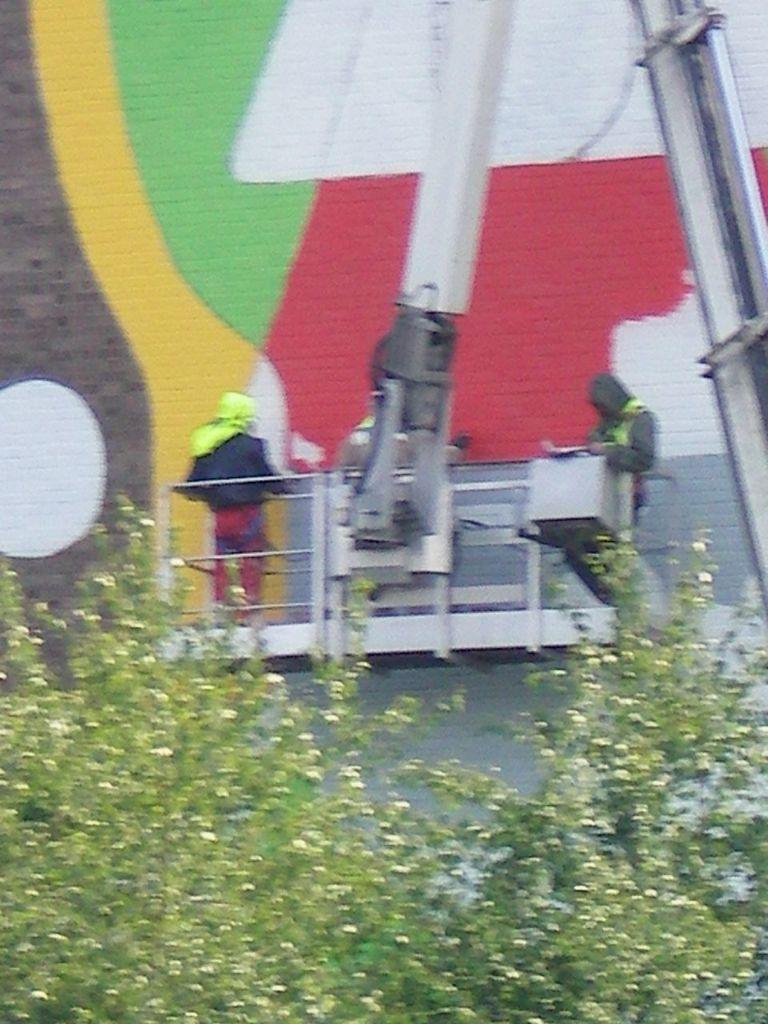Can you describe this image briefly? Here in this picture we can see some people standing in an hydraulic lift of a crane present over there and they are painting the wall over there and in the front we can see trees present over there. 